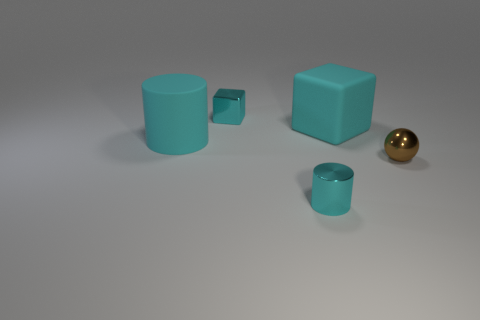Add 2 large things. How many objects exist? 7 Subtract all spheres. How many objects are left? 4 Add 4 cyan cylinders. How many cyan cylinders exist? 6 Subtract 0 yellow cylinders. How many objects are left? 5 Subtract all purple shiny balls. Subtract all tiny brown balls. How many objects are left? 4 Add 2 large cyan matte cylinders. How many large cyan matte cylinders are left? 3 